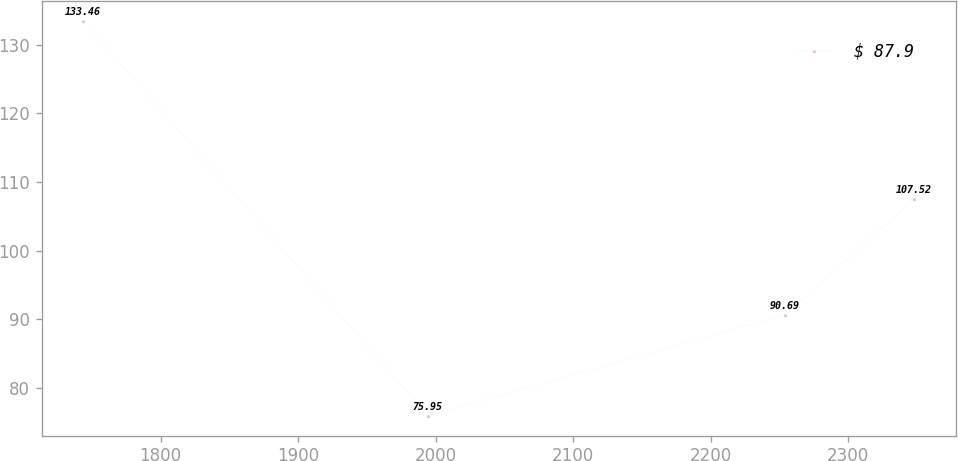Convert chart to OTSL. <chart><loc_0><loc_0><loc_500><loc_500><line_chart><ecel><fcel>$ 87.9<nl><fcel>1743.85<fcel>133.46<nl><fcel>1994.72<fcel>75.95<nl><fcel>2254.42<fcel>90.69<nl><fcel>2348.13<fcel>107.52<nl></chart> 